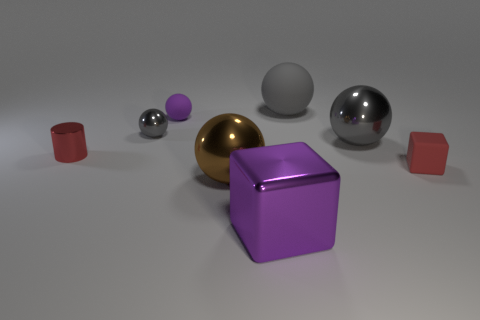Subtract all gray balls. How many were subtracted if there are1gray balls left? 2 Add 1 balls. How many objects exist? 9 Subtract all small matte spheres. How many spheres are left? 4 Subtract 1 blocks. How many blocks are left? 1 Subtract all gray spheres. How many spheres are left? 2 Subtract all small cyan metallic cylinders. Subtract all gray balls. How many objects are left? 5 Add 5 tiny red metal cylinders. How many tiny red metal cylinders are left? 6 Add 7 cyan cylinders. How many cyan cylinders exist? 7 Subtract 0 green blocks. How many objects are left? 8 Subtract all balls. How many objects are left? 3 